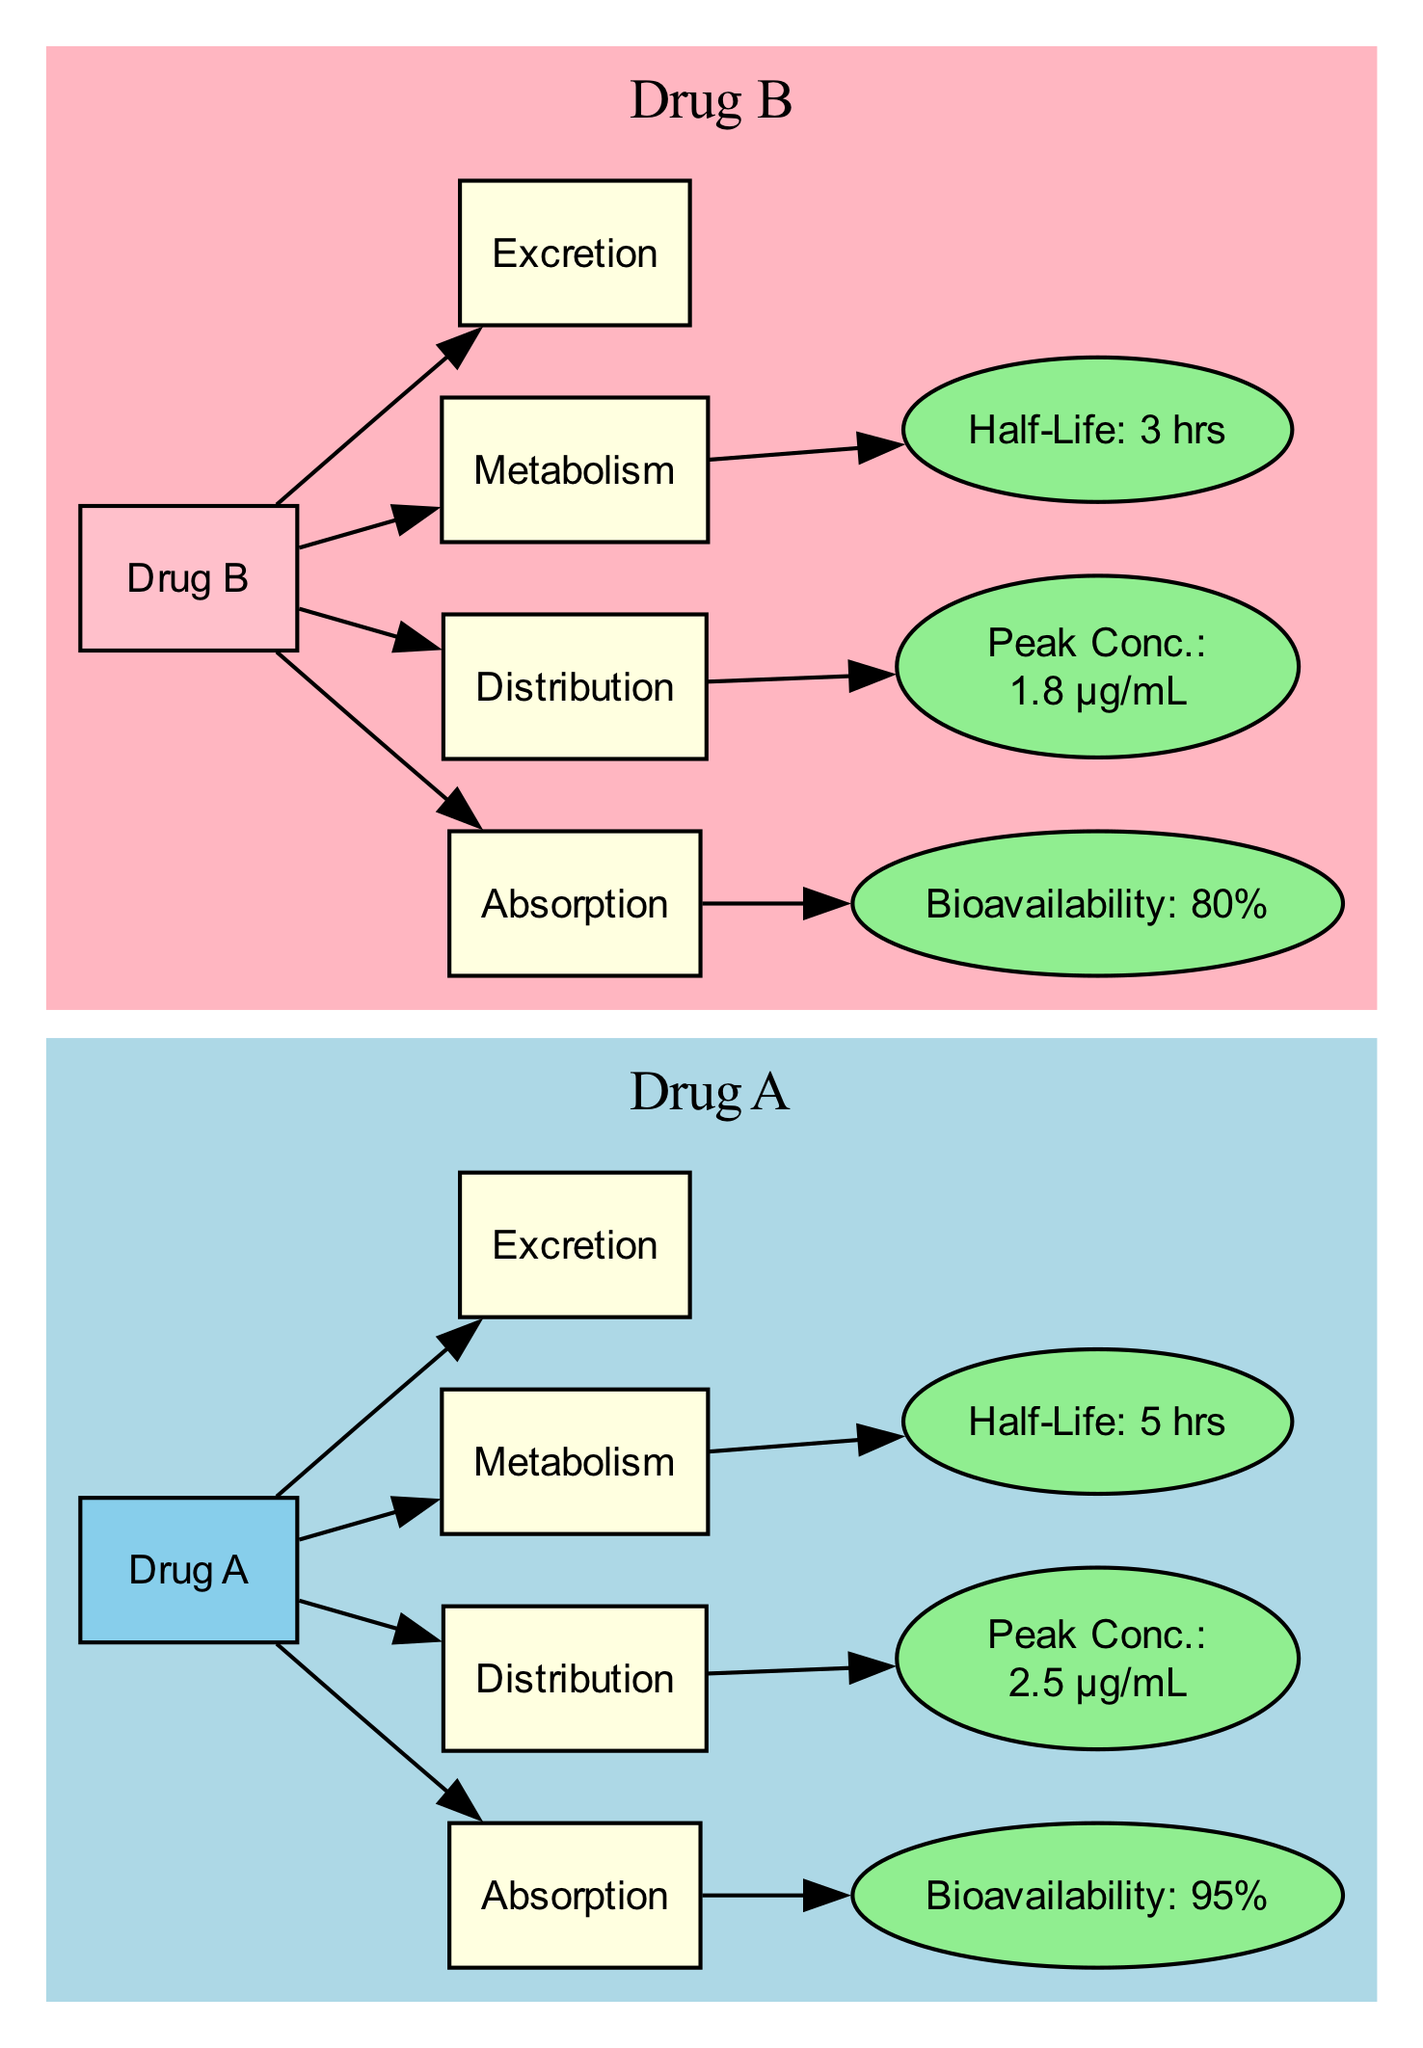What is the bioavailability of Drug A? The diagram clearly indicates that the bioavailability for Drug A is shown in the node labeled "Bioavailability: 95%." Therefore, the answer is 95%.
Answer: 95% What is the half-life of Drug B? In the diagram, the half-life for Drug B is indicated in the node labeled "Half-Life: 3 hrs." Thus, the answer is 3 hours.
Answer: 3 hrs Which drug has a higher peak concentration? The diagram shows that Peak Concentration for Drug A is labeled "Peak Conc.: 2.5 µg/mL" and for Drug B is "Peak Conc.: 1.8 µg/mL." Comparing these values, Drug A has the higher peak concentration.
Answer: Drug A How many nodes are dedicated to metabolism in the diagram? By examining the diagram, there are two nodes labeled for metabolism: "Metabolism A" and "Metabolism B." Therefore, the count yields a total of 2 metabolism nodes.
Answer: 2 What is the relationship between absorption and bioavailability for Drug B? The edges from nodes indicate that "Absorption" connects to "Bioavailability" for Drug B (Absorption B to Bioavailability B). This shows that absorption influences the bioavailability of Drug B.
Answer: Absorption influences bioavailability Which drug has a longer half-life? The half-lives are "Half-Life: 5 hrs" for Drug A and "Half-Life: 3 hrs" for Drug B. To determine which one is longer, we can see 5 hours is greater than 3 hours, indicating Drug A has a longer half-life.
Answer: Drug A What color represents the distribution nodes in the diagram? The nodes for distribution are colored light yellow as indicated in the subgraphs for both drugs. Thus, the color associated with distribution nodes is light yellow.
Answer: Light yellow What is the peak concentration for Drug A? The diagram directly specifies the peak concentration of Drug A in the node labeled "Peak Conc.: 2.5 µg/mL." Thus, the answer can be directly derived as 2.5 µg/mL.
Answer: 2.5 µg/mL Which drug has a bioavailability percentage lower than 90%? Upon examining the bioavailability percentages, Drug A has 95% while Drug B has 80%. Since 80% is lower than 90%, Drug B meets the criterion of having a bioavailability percentage lower than 90%.
Answer: Drug B 